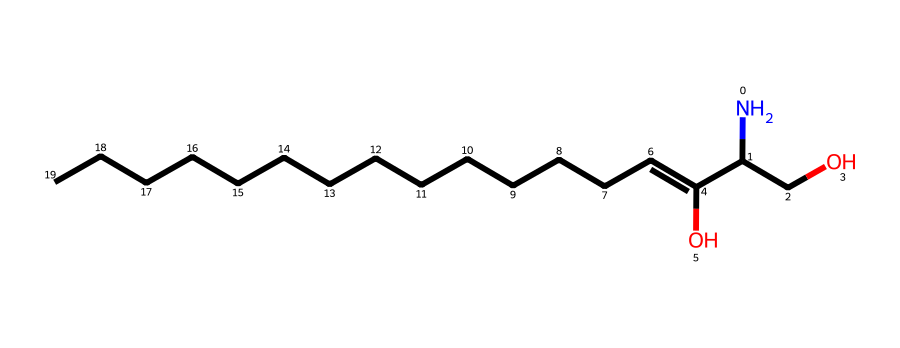What is the molecular formula of this chemical? By analyzing the SMILES representation, we can determine the number of each type of atom present. The SMILES notation includes nitrogen (N), carbon (C), and oxygen (O) atoms. Counting these, we find: C (18), H (39), N (1), and O (2), leading us to the molecular formula C18H39NO2.
Answer: C18H39NO2 How many carbon atoms are present in this sphingolipid? The SMILES notation reveals the presence of 18 carbon atoms (C) within the structure. We count the C symbols to find the total.
Answer: 18 What is the role of the hydroxyl group in the structure? The hydroxyl group (-OH) present in the structure imparts polar characteristics, contributing to the interactions with aqueous environments, making it significant for functions in signal transduction.
Answer: polar interactions Which functional group indicates this molecule is a sphingolipid? The presence of a sphingosine backbone is indicated by the amine group (NH) connected to a long hydrocarbon chain, which is characteristic of sphingolipids. This helps categorize the compound appropriately.
Answer: amine group How many double bonds are there in this molecule? From the structure indicated in the SMILES, we examine the connections between carbon atoms. There are no explicit double bonds shown in this representation; therefore, the count is zero.
Answer: 0 What is the significance of the long hydrocarbon chain in sphingolipid function? The long hydrocarbon chain contributes to membrane structure and fluidity, enabling sphingolipids to participate in the formation of lipid rafts, which are crucial for signal transduction pathways.
Answer: membrane structure What type of lipid does this compound belong to? Based on the structure and functional groups present in the SMILES representation, this compound is classified as a sphingolipid, which is characterized by its sphingosine backbone.
Answer: sphingolipid 